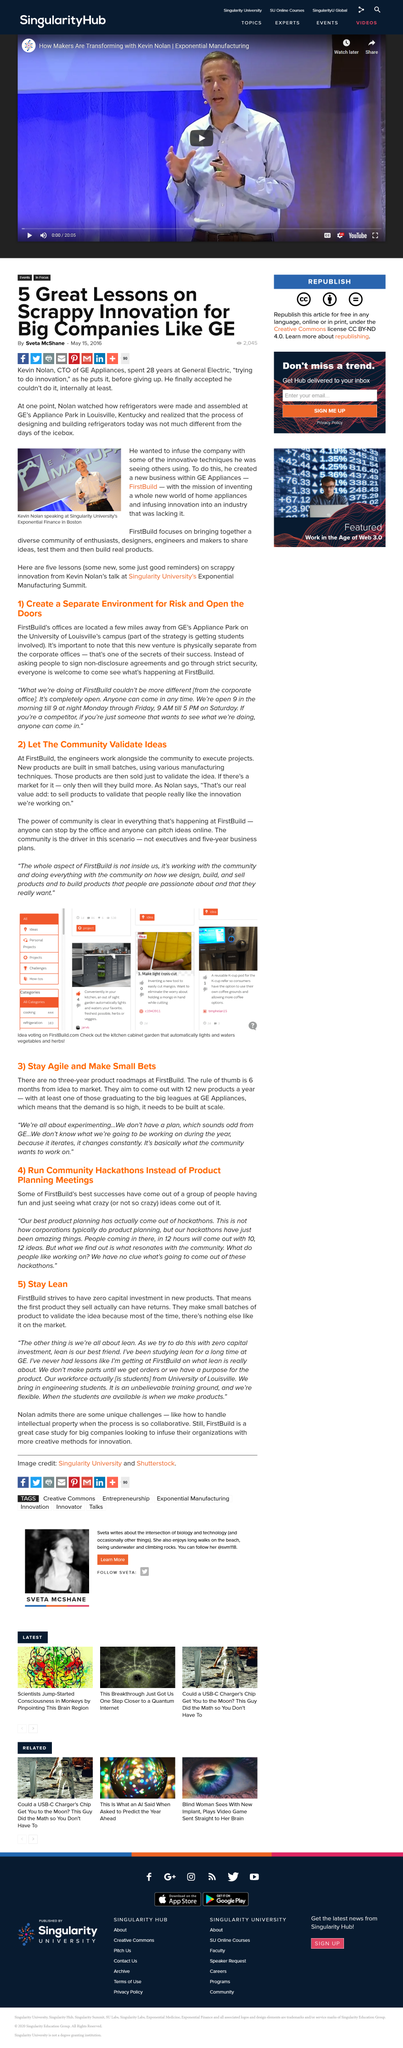List a handful of essential elements in this visual. Firstbuild's success can be attributed to physically separating itself from the corporate office. Kevin Nolan was speaking in a city that was located in Boston. The speaker in the photo is named Kevin Nolam and should be referred to as such. Firstbuild maintains its offices in proximity to Ge's Appliance Park, specifically on the University of Louisville's campus, a short distance away. Kevin Nolan spent a total of 28 years at General Electric. 